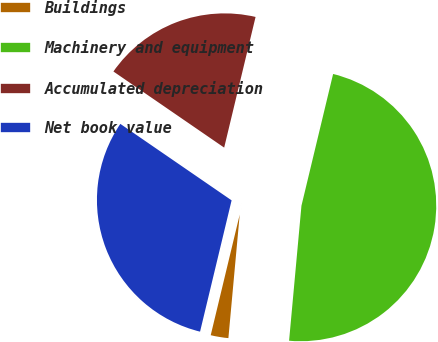Convert chart to OTSL. <chart><loc_0><loc_0><loc_500><loc_500><pie_chart><fcel>Buildings<fcel>Machinery and equipment<fcel>Accumulated depreciation<fcel>Net book value<nl><fcel>2.3%<fcel>47.7%<fcel>19.17%<fcel>30.83%<nl></chart> 